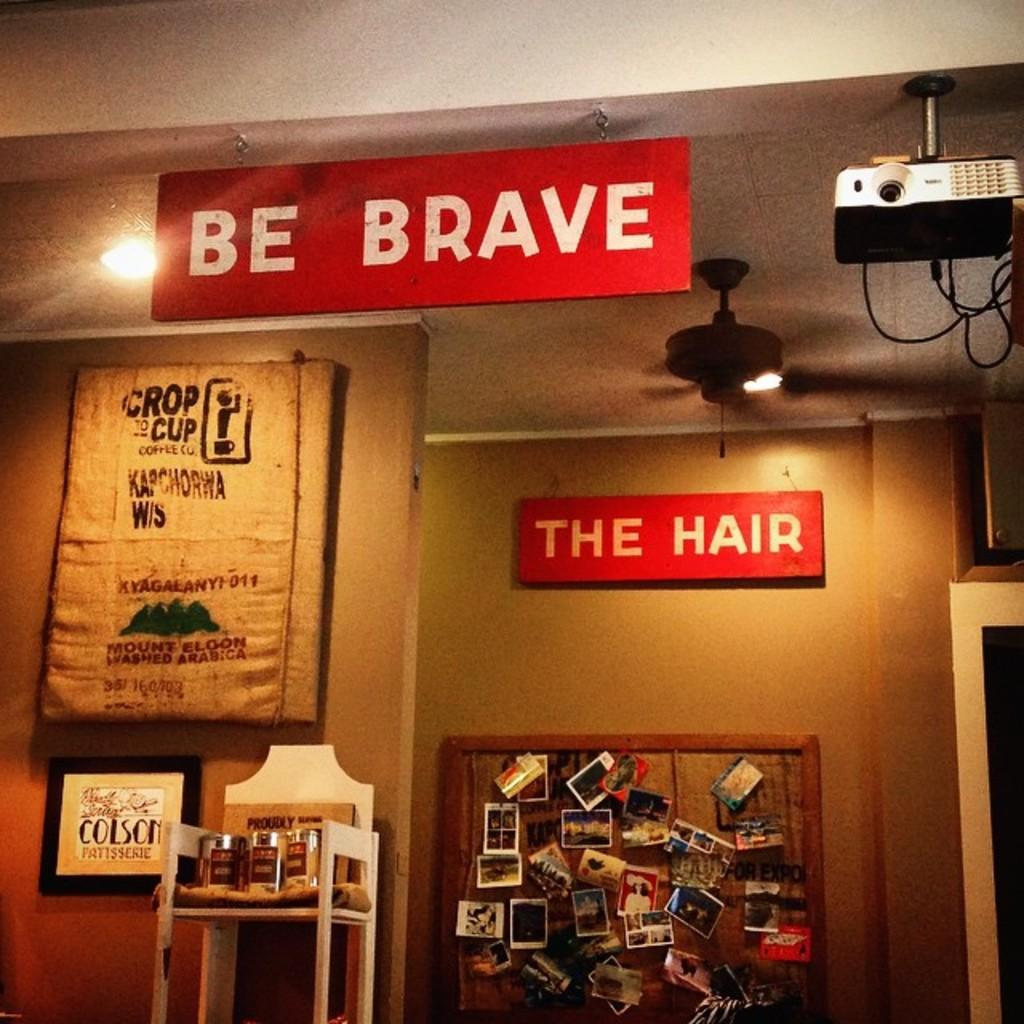<image>
Summarize the visual content of the image. Be Brave hair store showing various hair products 